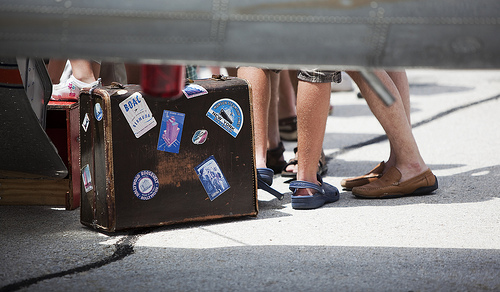<image>
Is the skyscraper on the suitcase? Yes. Looking at the image, I can see the skyscraper is positioned on top of the suitcase, with the suitcase providing support. 